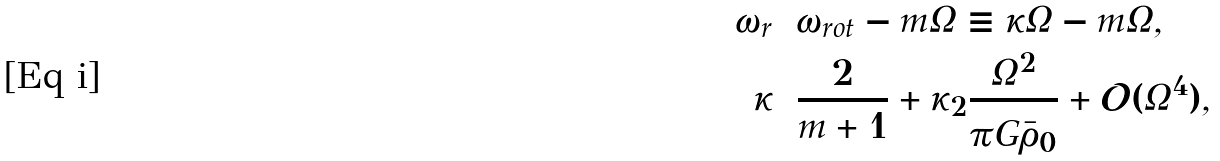Convert formula to latex. <formula><loc_0><loc_0><loc_500><loc_500>\omega _ { r } & = \omega _ { r o t } - m \Omega \equiv \kappa \Omega - m \Omega , \\ \kappa & = \frac { 2 } { m + 1 } + \kappa _ { 2 } \frac { \Omega ^ { 2 } } { \pi G \bar { \rho } _ { 0 } } + \mathcal { O } ( \Omega ^ { 4 } ) ,</formula> 